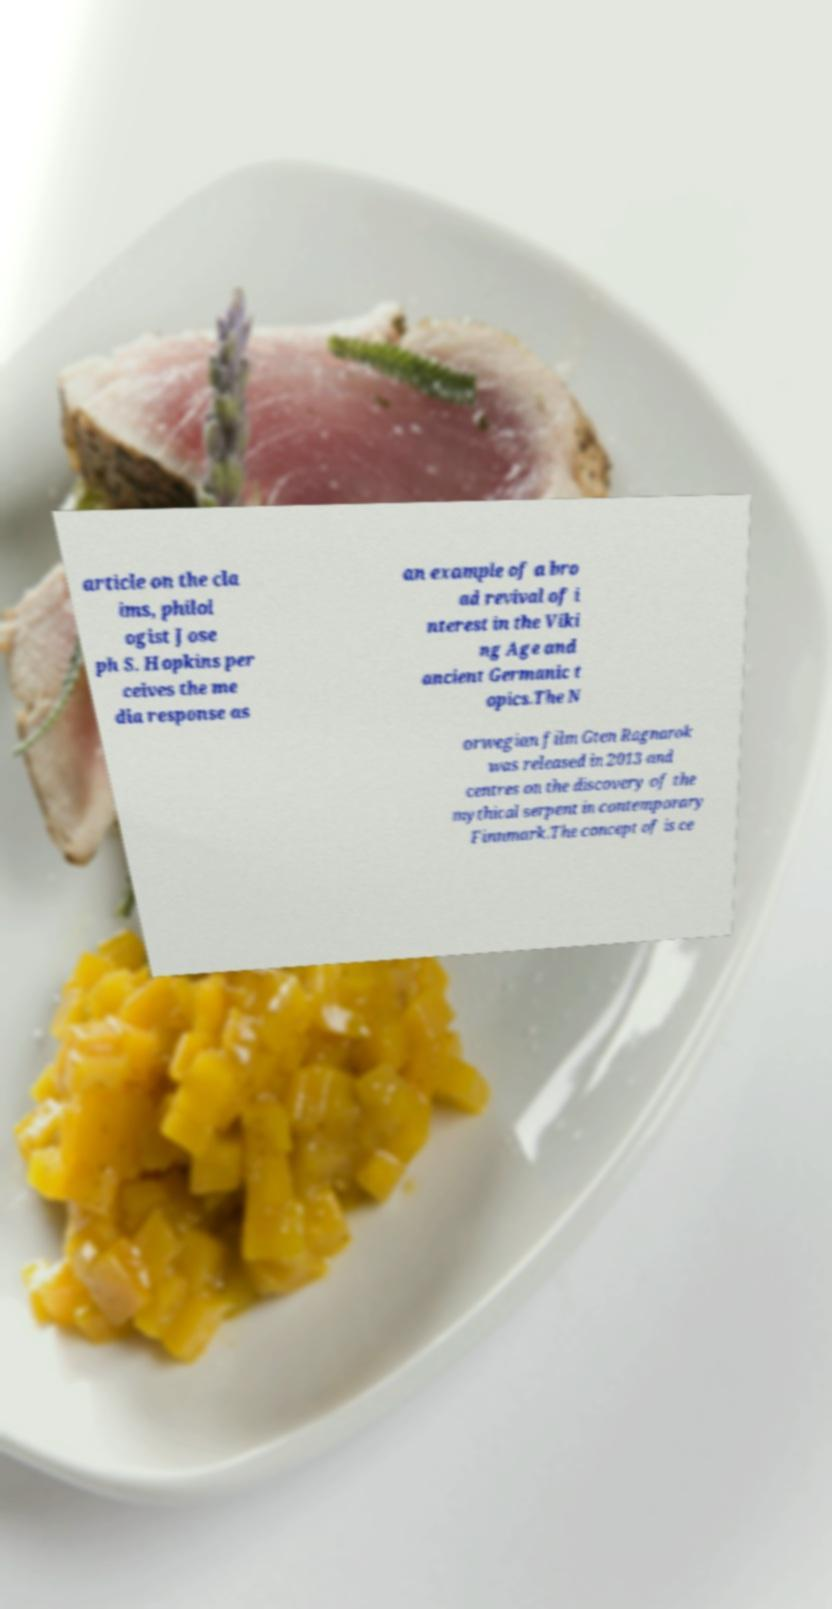Could you extract and type out the text from this image? article on the cla ims, philol ogist Jose ph S. Hopkins per ceives the me dia response as an example of a bro ad revival of i nterest in the Viki ng Age and ancient Germanic t opics.The N orwegian film Gten Ragnarok was released in 2013 and centres on the discovery of the mythical serpent in contemporary Finnmark.The concept of is ce 